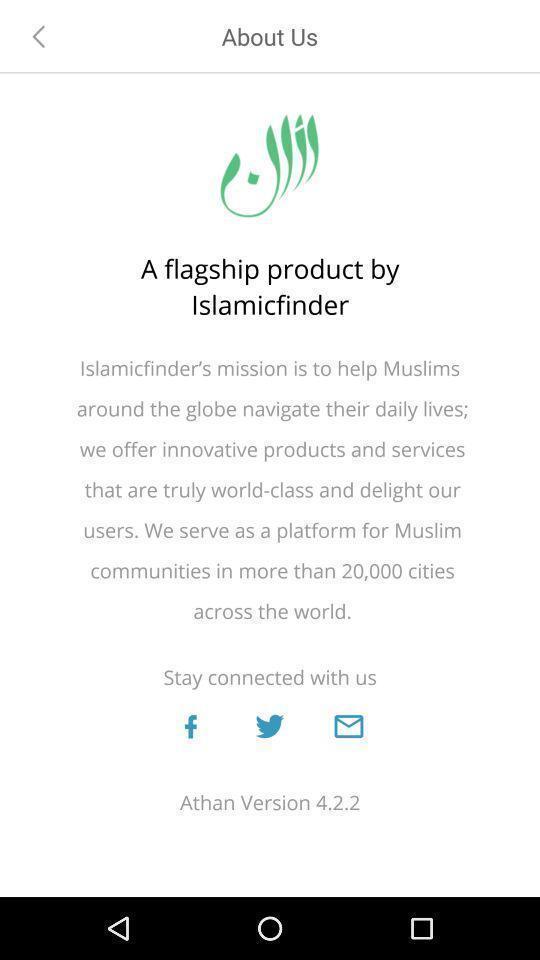Describe the key features of this screenshot. Page showing the disclaimer information. 